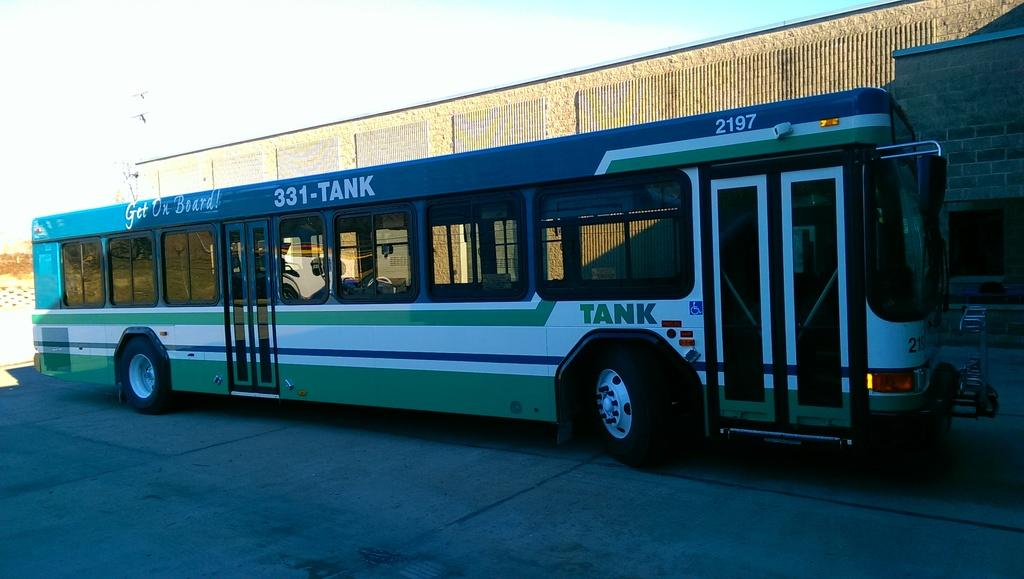What type of vehicle is on the road in the image? There is a bus on the road in the image. What structure can be seen in the image? There is a building in the image. What can be seen in the background of the image? The sky is visible in the background of the image. How many pages of paper are being read by the person in the image? There is no person present in the image, and therefore no one is reading any paper. 